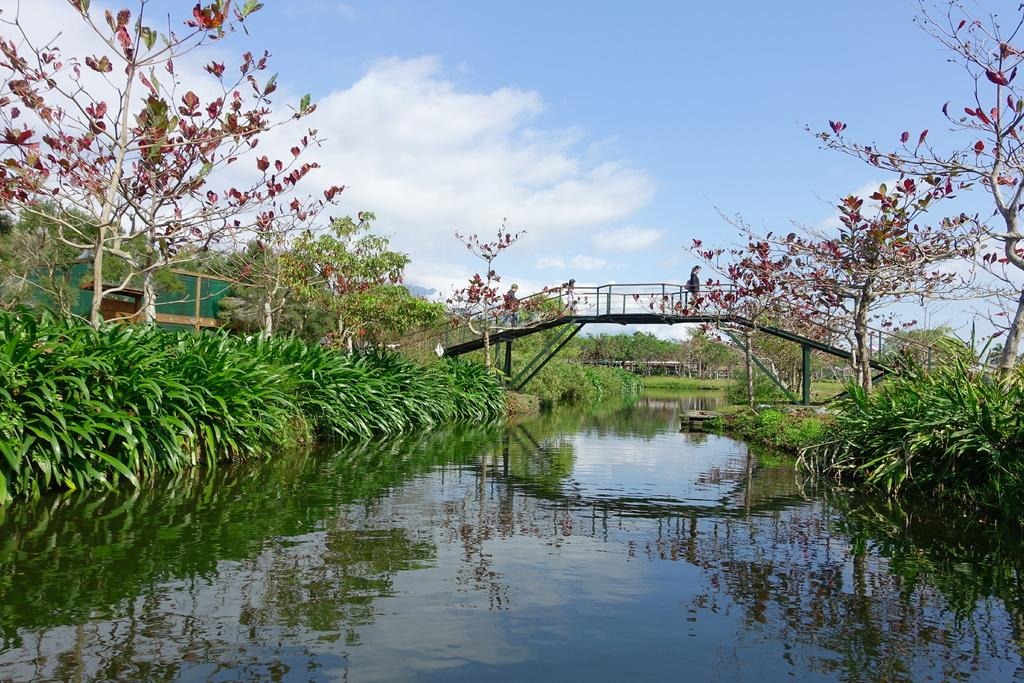What type of vegetation can be seen in the image? There are trees in the image. What natural element is present alongside the trees? There is water in the image. What structure is present above the water? There is a bridge above the water. Are there any people visible in the image? Yes, there are persons on the bridge. What can be seen in the background of the image? The sky is visible in the background of the image. What type of cattle can be heard making a voice in the image? There is no cattle or voice present in the image; it features trees, water, a bridge, and persons on the bridge. Can you describe the beetle crawling on the bridge in the image? There is no beetle present in the image; it only features trees, water, a bridge, and persons on the bridge. 